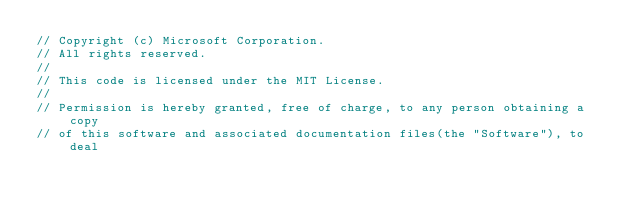Convert code to text. <code><loc_0><loc_0><loc_500><loc_500><_Java_>// Copyright (c) Microsoft Corporation.
// All rights reserved.
//
// This code is licensed under the MIT License.
//
// Permission is hereby granted, free of charge, to any person obtaining a copy
// of this software and associated documentation files(the "Software"), to deal</code> 